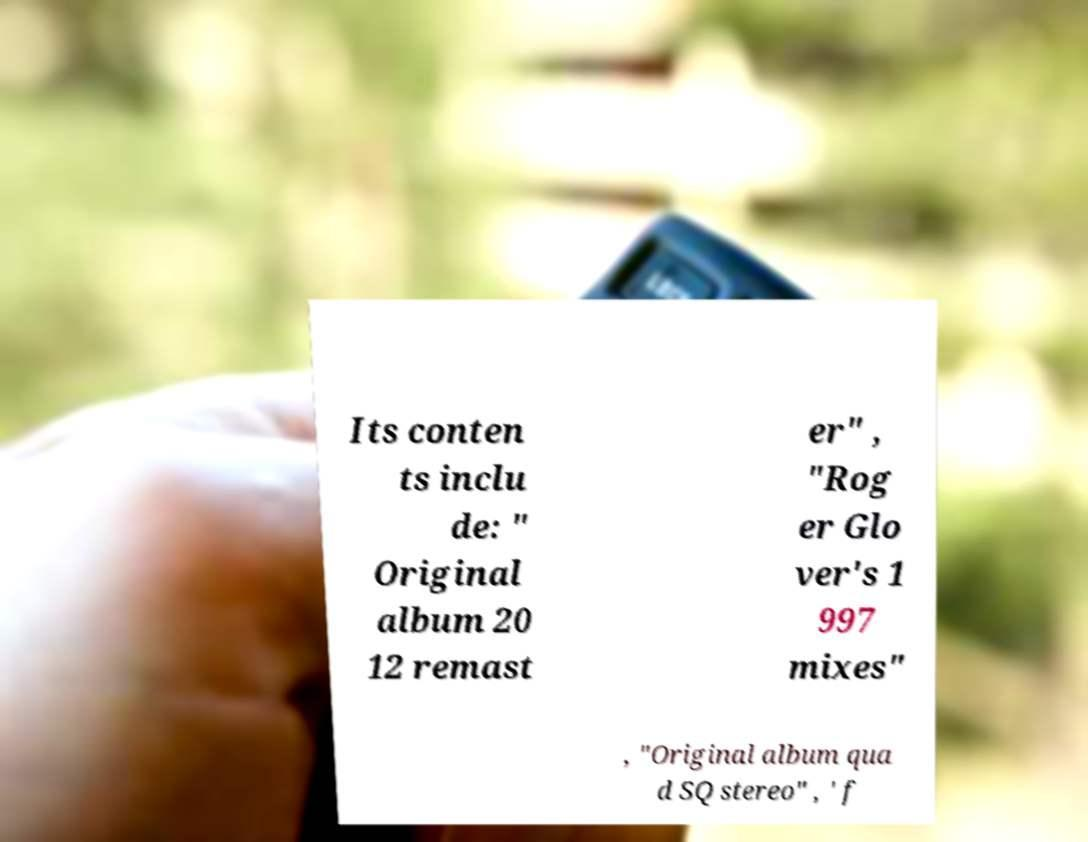For documentation purposes, I need the text within this image transcribed. Could you provide that? Its conten ts inclu de: " Original album 20 12 remast er" , "Rog er Glo ver's 1 997 mixes" , "Original album qua d SQ stereo" , ' f 